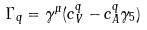<formula> <loc_0><loc_0><loc_500><loc_500>\Gamma _ { q } = \gamma ^ { \mu } ( c _ { V } ^ { q } - c _ { A } ^ { q } \gamma _ { 5 } ) \\</formula> 